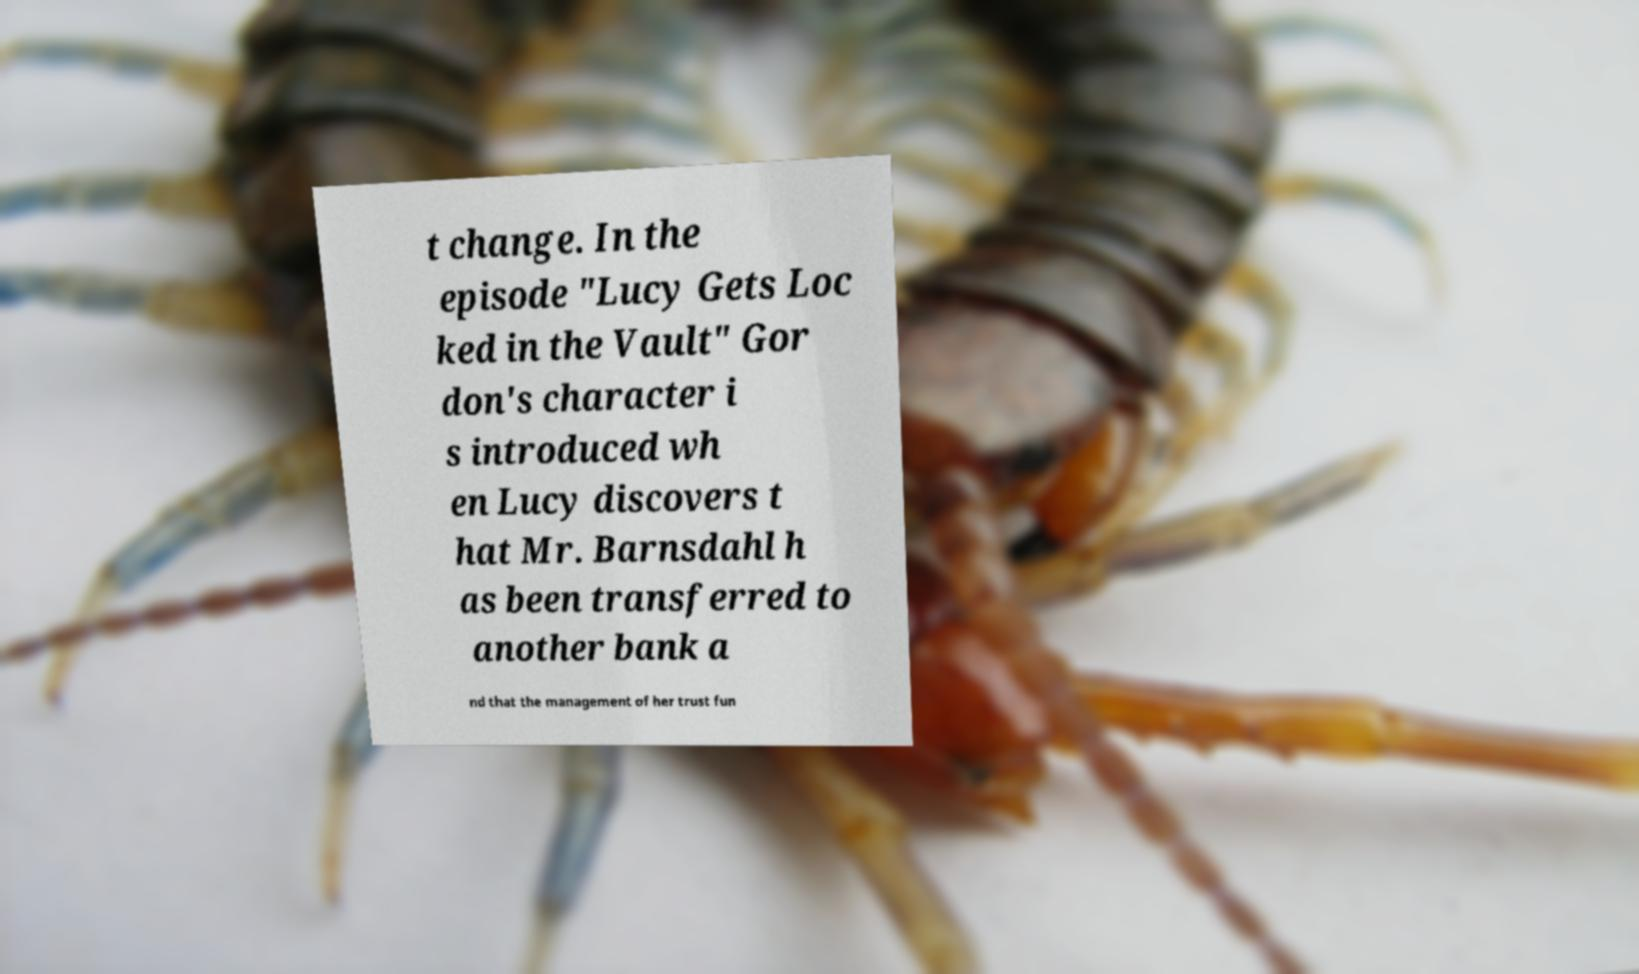For documentation purposes, I need the text within this image transcribed. Could you provide that? t change. In the episode "Lucy Gets Loc ked in the Vault" Gor don's character i s introduced wh en Lucy discovers t hat Mr. Barnsdahl h as been transferred to another bank a nd that the management of her trust fun 